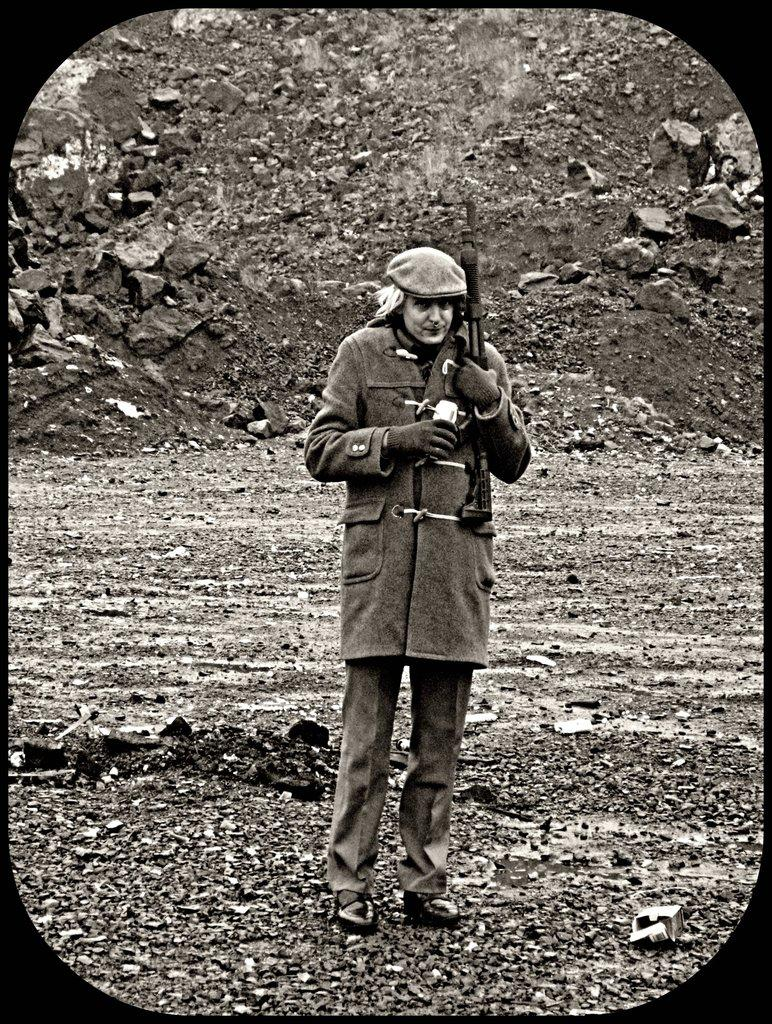What is the person in the image doing? The person is standing in the image. What is the person standing on? The person is standing on the ground. What object is the person holding in the image? The person is holding a gun. What can be seen in the background of the image? There are stones and soil visible in the background of the image. What type of yarn is the person using to rub the tail of the animal in the image? There is no animal or yarn present in the image; the person is holding a gun and standing on the ground. 